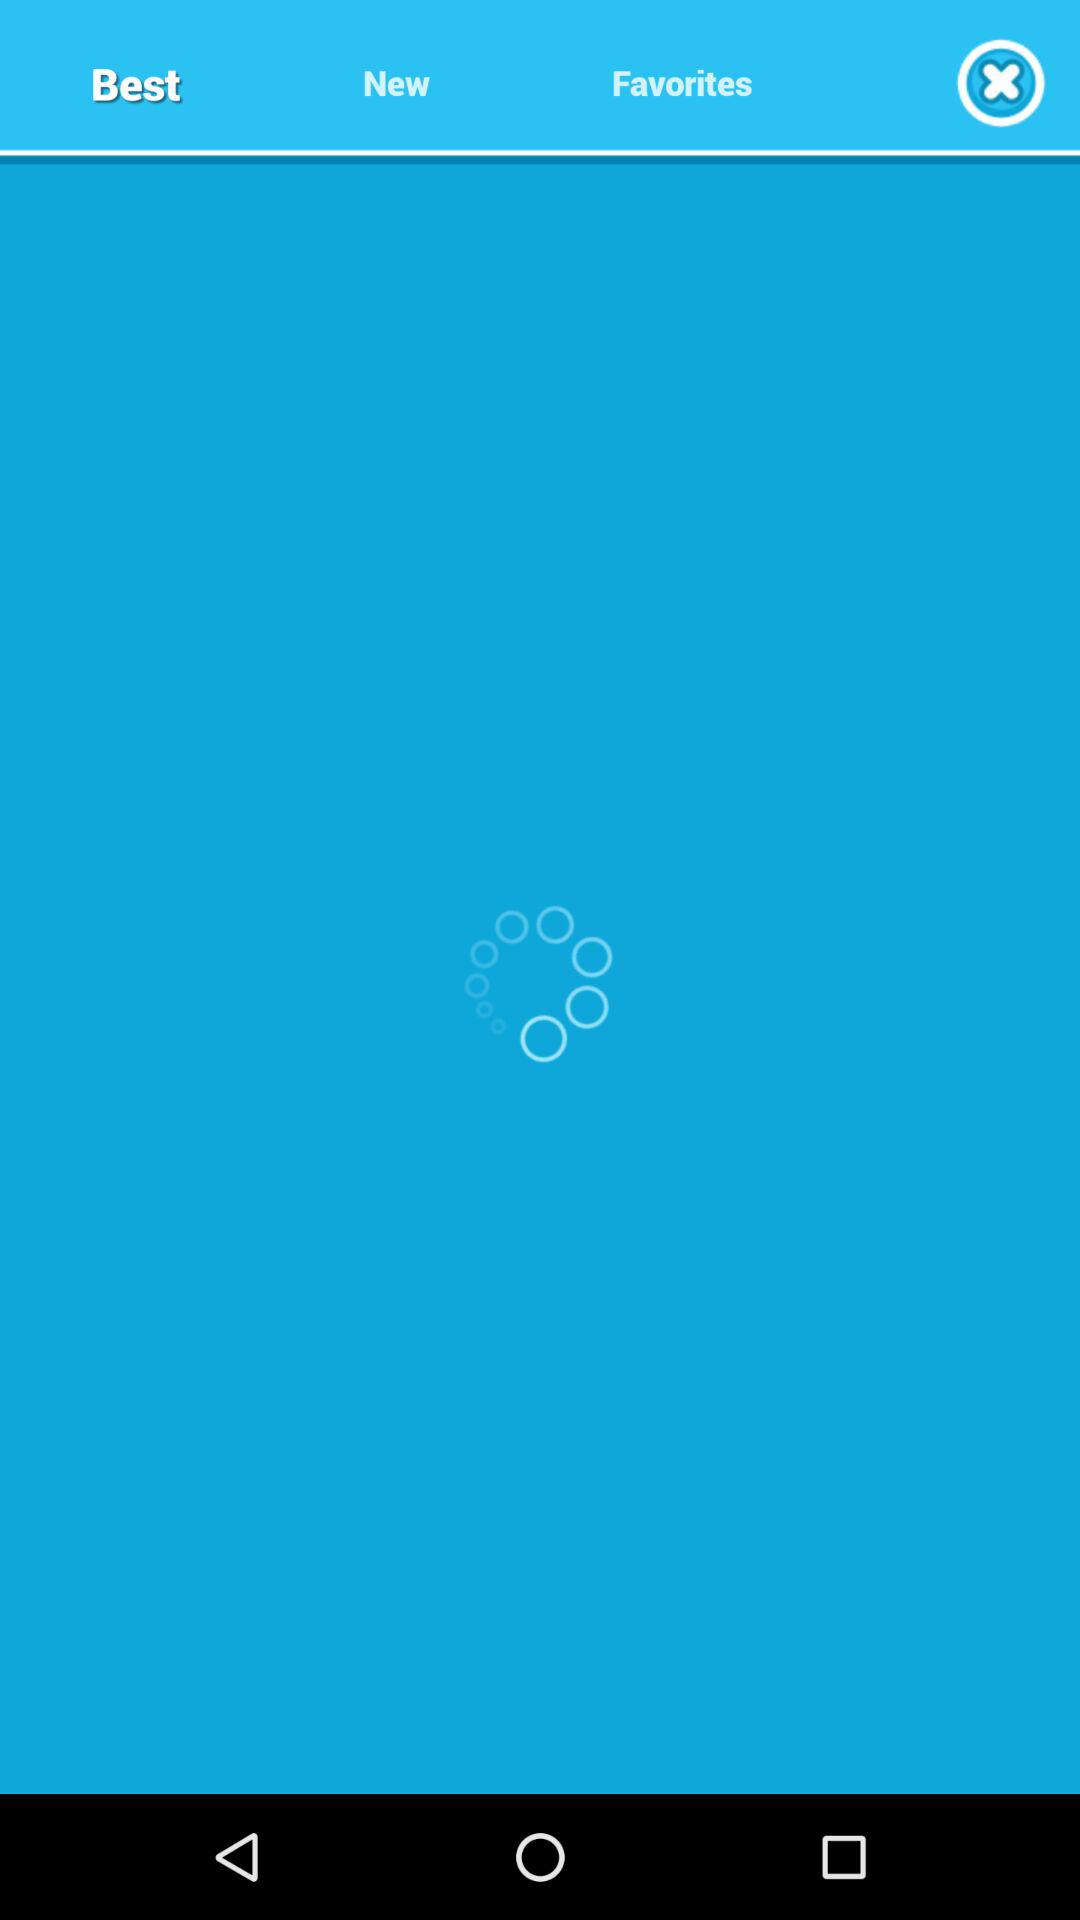Which items are in "Best"?
When the provided information is insufficient, respond with <no answer>. <no answer> 